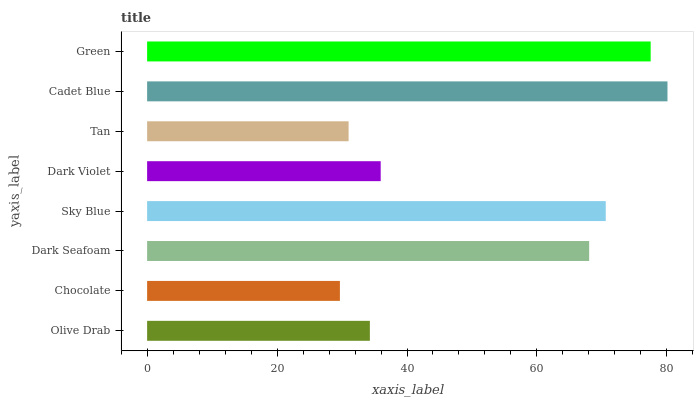Is Chocolate the minimum?
Answer yes or no. Yes. Is Cadet Blue the maximum?
Answer yes or no. Yes. Is Dark Seafoam the minimum?
Answer yes or no. No. Is Dark Seafoam the maximum?
Answer yes or no. No. Is Dark Seafoam greater than Chocolate?
Answer yes or no. Yes. Is Chocolate less than Dark Seafoam?
Answer yes or no. Yes. Is Chocolate greater than Dark Seafoam?
Answer yes or no. No. Is Dark Seafoam less than Chocolate?
Answer yes or no. No. Is Dark Seafoam the high median?
Answer yes or no. Yes. Is Dark Violet the low median?
Answer yes or no. Yes. Is Olive Drab the high median?
Answer yes or no. No. Is Dark Seafoam the low median?
Answer yes or no. No. 